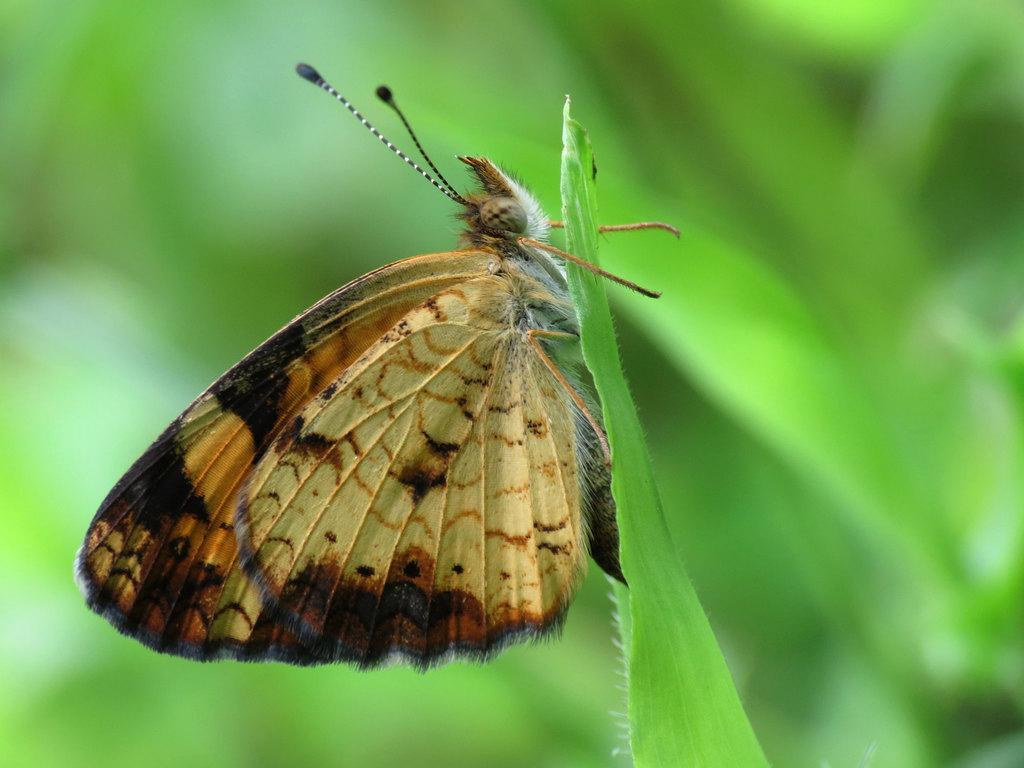What is the main subject of the image? There is a butterfly in the image. Where is the butterfly located? The butterfly is on a leaf. Can you describe the background of the image? The background of the image is blurry. What type of elbow can be seen in the image? There is no elbow present in the image; it features a butterfly on a leaf. Can you provide an example of a ship in the image? There is no ship present in the image. 